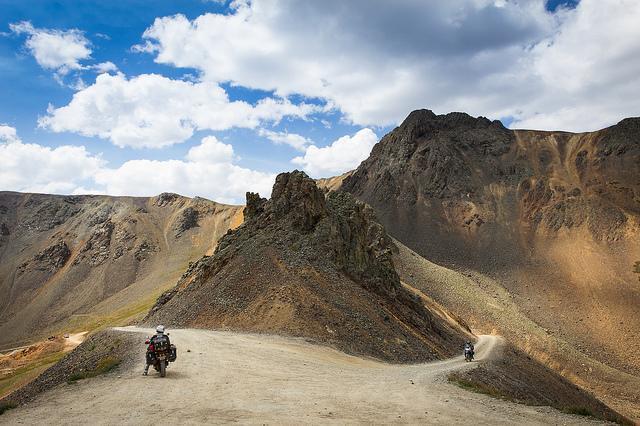How many people are in the picture?
Give a very brief answer. 1. How many motorcycles are on the dirt road?
Give a very brief answer. 2. 